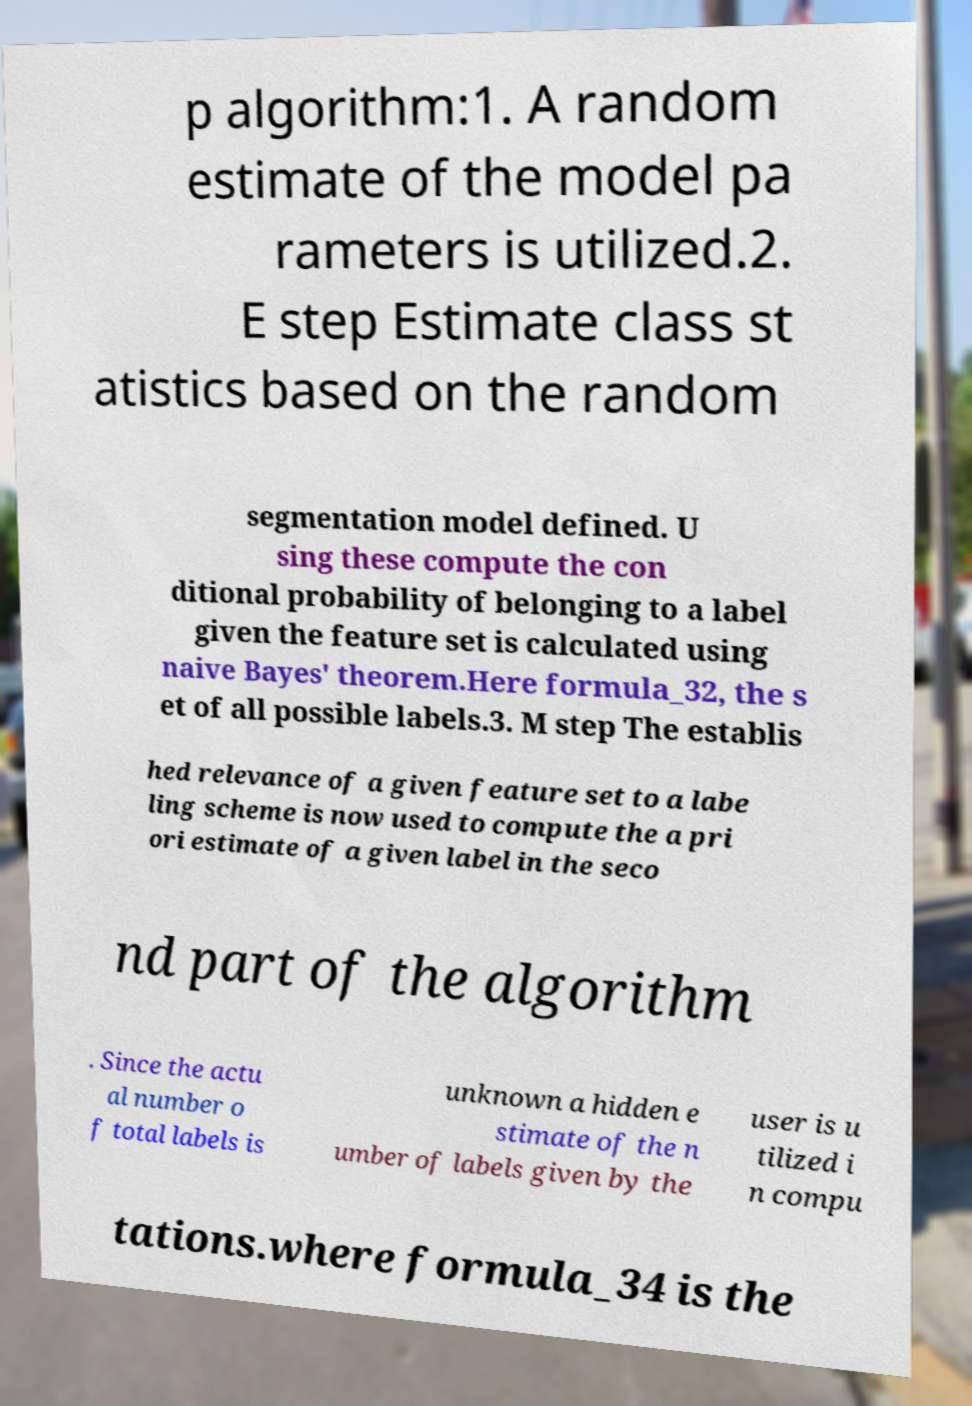Please identify and transcribe the text found in this image. p algorithm:1. A random estimate of the model pa rameters is utilized.2. E step Estimate class st atistics based on the random segmentation model defined. U sing these compute the con ditional probability of belonging to a label given the feature set is calculated using naive Bayes' theorem.Here formula_32, the s et of all possible labels.3. M step The establis hed relevance of a given feature set to a labe ling scheme is now used to compute the a pri ori estimate of a given label in the seco nd part of the algorithm . Since the actu al number o f total labels is unknown a hidden e stimate of the n umber of labels given by the user is u tilized i n compu tations.where formula_34 is the 